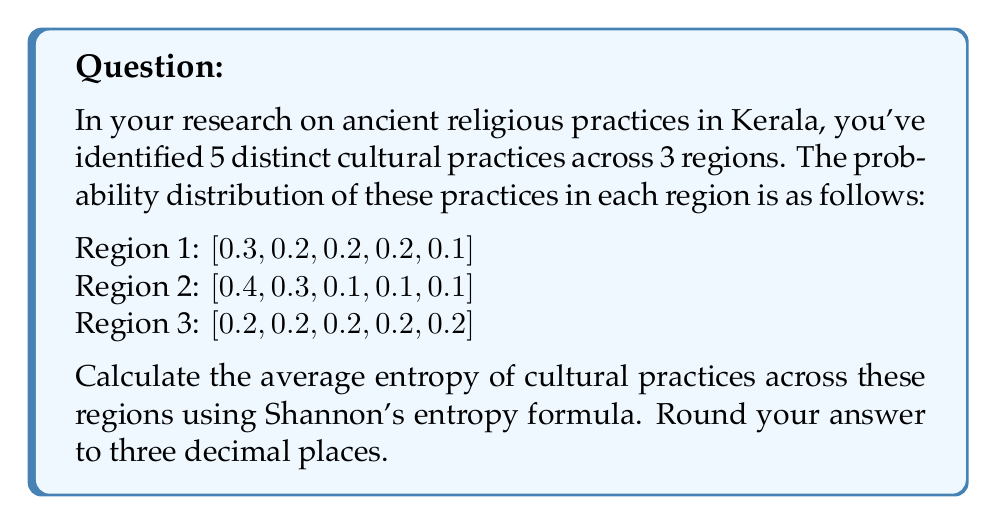Show me your answer to this math problem. To solve this problem, we'll follow these steps:

1) Recall Shannon's entropy formula:
   $H = -\sum_{i=1}^{n} p_i \log_2(p_i)$

2) Calculate the entropy for each region:

   Region 1:
   $H_1 = -[0.3\log_2(0.3) + 0.2\log_2(0.2) + 0.2\log_2(0.2) + 0.2\log_2(0.2) + 0.1\log_2(0.1)]$
   $H_1 = 2.221$ bits

   Region 2:
   $H_2 = -[0.4\log_2(0.4) + 0.3\log_2(0.3) + 0.1\log_2(0.1) + 0.1\log_2(0.1) + 0.1\log_2(0.1)]$
   $H_2 = 2.122$ bits

   Region 3:
   $H_3 = -[0.2\log_2(0.2) + 0.2\log_2(0.2) + 0.2\log_2(0.2) + 0.2\log_2(0.2) + 0.2\log_2(0.2)]$
   $H_3 = 2.322$ bits

3) Calculate the average entropy across all regions:
   $H_{avg} = \frac{H_1 + H_2 + H_3}{3}$
   $H_{avg} = \frac{2.221 + 2.122 + 2.322}{3} = 2.222$ bits

4) Round to three decimal places: 2.222 bits
Answer: 2.222 bits 